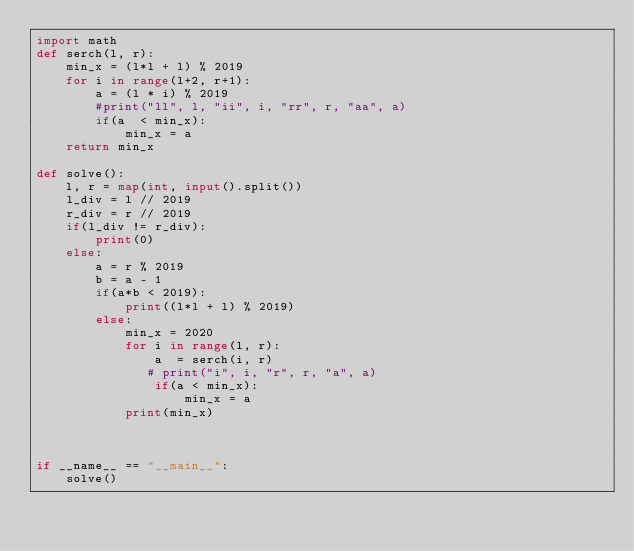Convert code to text. <code><loc_0><loc_0><loc_500><loc_500><_Python_>import math
def serch(l, r):
    min_x = (l*l + l) % 2019
    for i in range(l+2, r+1):
        a = (l * i) % 2019
        #print("ll", l, "ii", i, "rr", r, "aa", a)
        if(a  < min_x):
            min_x = a
    return min_x

def solve():
    l, r = map(int, input().split())
    l_div = l // 2019
    r_div = r // 2019
    if(l_div != r_div):
        print(0)
    else:
        a = r % 2019
        b = a - 1
        if(a*b < 2019):
            print((l*l + l) % 2019)
        else:
            min_x = 2020
            for i in range(l, r):
                a  = serch(i, r)
               # print("i", i, "r", r, "a", a)
                if(a < min_x):
                    min_x = a
            print(min_x)



if __name__ == "__main__":
    solve()</code> 